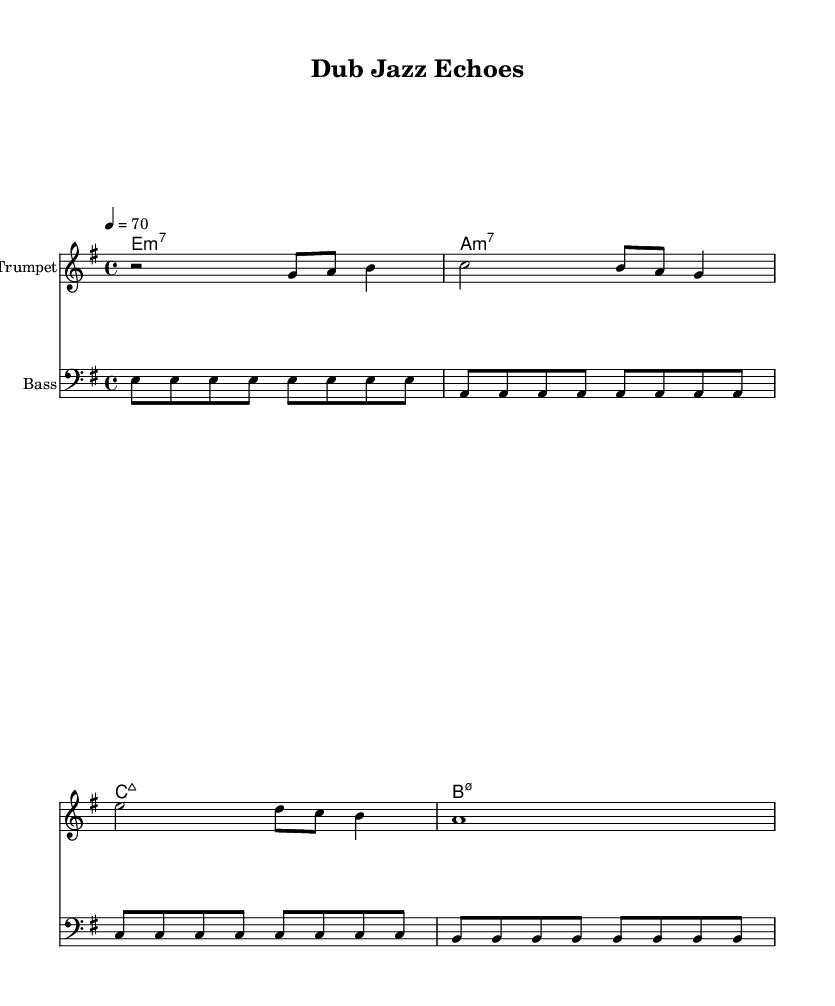What is the key signature of this music? The key signature is indicated at the beginning of the staff and shows three sharps, representing E minor.
Answer: E minor What is the time signature of this music? The time signature is found after the key signature, represented by the fraction 4/4, meaning there are four beats in each measure.
Answer: 4/4 What is the tempo marking of this music? The tempo marking is indicated by the text "4 = 70," suggesting that there are 70 quarter-note beats per minute.
Answer: 70 How many measures are in the bass line? The bass line is visually divided into four measures, each separated by bar lines. Counting each group of notes confirms there are four.
Answer: Four Which chord is played in the first measure? The chords are listed above the staves, and the first chord indicated is E minor seven.
Answer: E minor seven What is the rhythmic feel of the trumpet melody? The trumpet melody incorporates a mix of quarter notes and eighth notes, creating a syncopated rhythmic feel typical of jazz influences.
Answer: Syncopated What style does this piece incorporate beyond reggae? Analyzing the elements present, the inclusion of avant-garde techniques and improvisational nuances suggests an experimental jazz influence.
Answer: Experimental jazz 